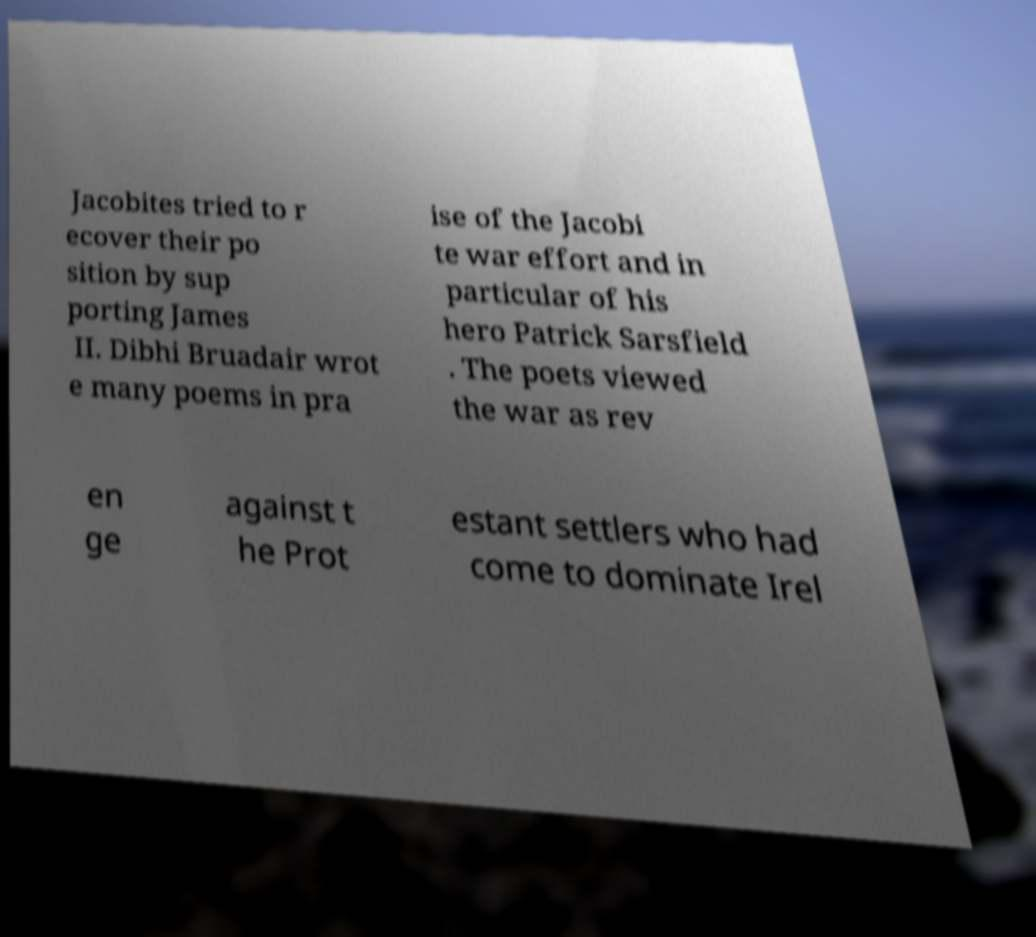Can you read and provide the text displayed in the image?This photo seems to have some interesting text. Can you extract and type it out for me? Jacobites tried to r ecover their po sition by sup porting James II. Dibhi Bruadair wrot e many poems in pra ise of the Jacobi te war effort and in particular of his hero Patrick Sarsfield . The poets viewed the war as rev en ge against t he Prot estant settlers who had come to dominate Irel 